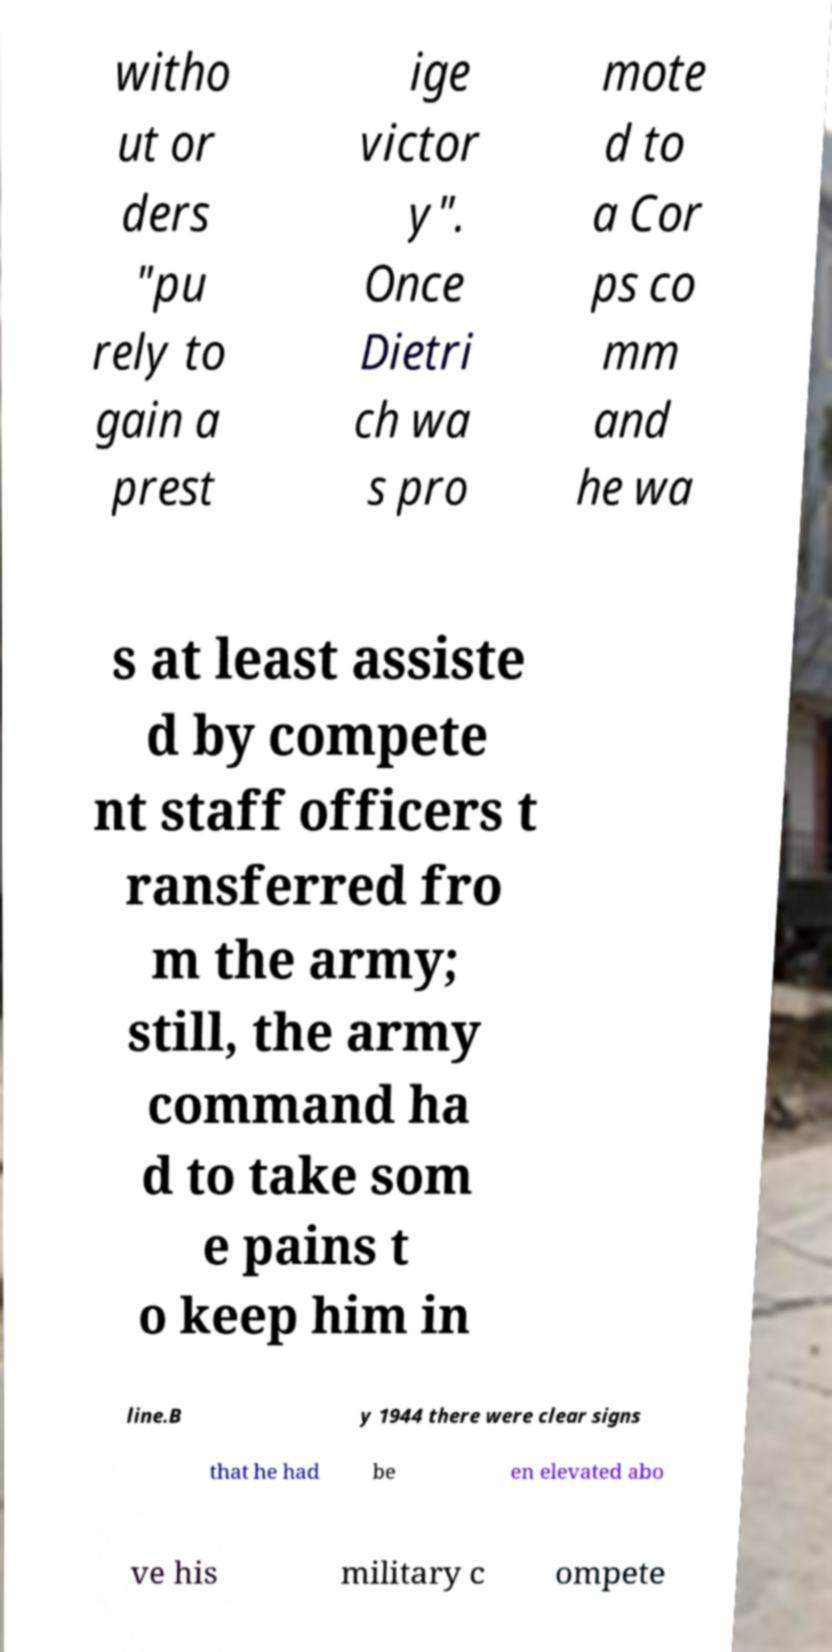Could you assist in decoding the text presented in this image and type it out clearly? witho ut or ders "pu rely to gain a prest ige victor y". Once Dietri ch wa s pro mote d to a Cor ps co mm and he wa s at least assiste d by compete nt staff officers t ransferred fro m the army; still, the army command ha d to take som e pains t o keep him in line.B y 1944 there were clear signs that he had be en elevated abo ve his military c ompete 